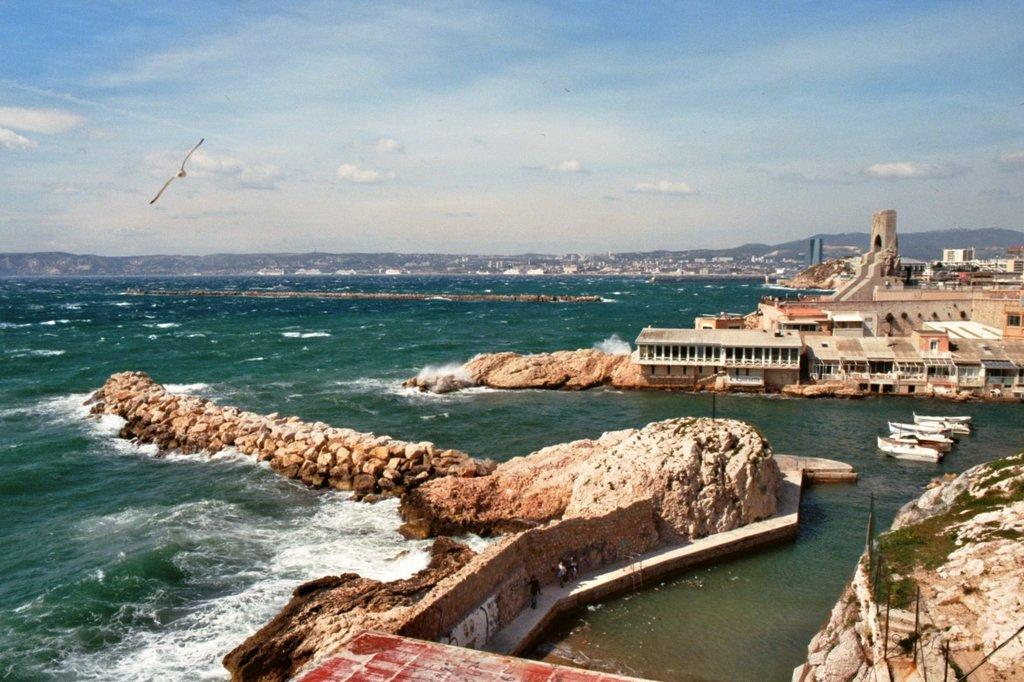What type of natural elements can be seen in the image? There are stones and rocks in the image. What man-made objects are present in the image? There are boats and buildings in the image. What is at the bottom of the image? There is water at the bottom of the image. What type of animal can be seen in the sky? There is a bird visible in the sky. What else can be seen in the sky? There are clouds in the sky. Where is the sister of the bird in the image? There is no mention of a sister for the bird in the image, nor is there any indication that the bird has a family. What type of wire can be seen connecting the boats in the image? There is no wire connecting the boats in the image; they are separate entities. 